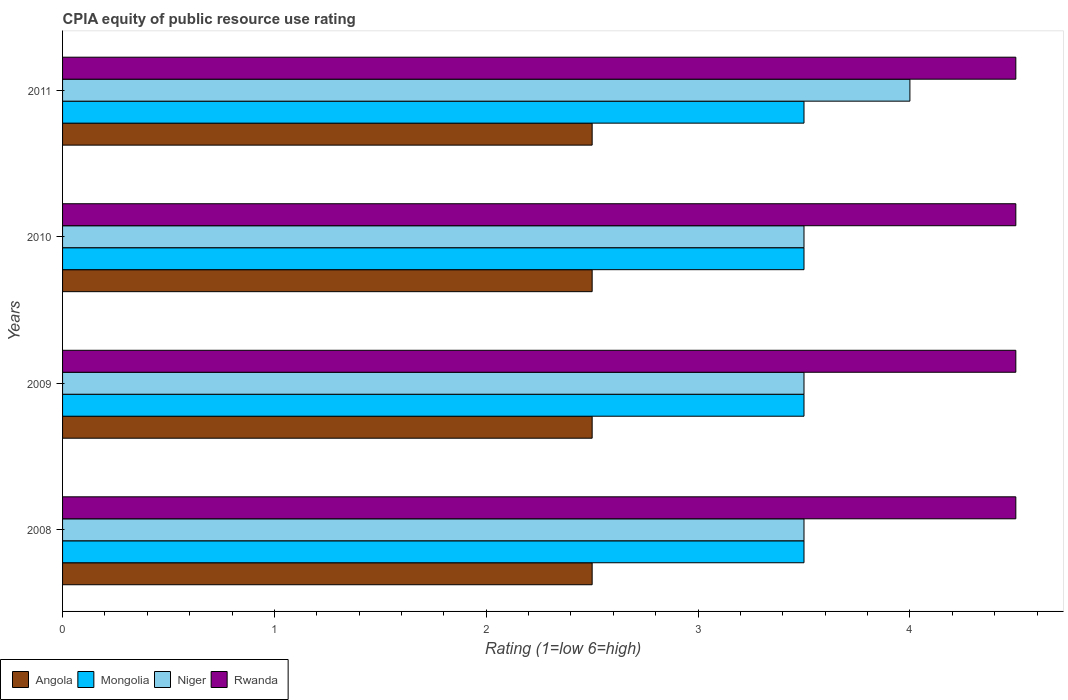How many different coloured bars are there?
Provide a short and direct response. 4. How many groups of bars are there?
Offer a terse response. 4. How many bars are there on the 3rd tick from the bottom?
Keep it short and to the point. 4. What is the label of the 2nd group of bars from the top?
Make the answer very short. 2010. In how many cases, is the number of bars for a given year not equal to the number of legend labels?
Your answer should be compact. 0. Across all years, what is the maximum CPIA rating in Niger?
Give a very brief answer. 4. In which year was the CPIA rating in Mongolia maximum?
Your answer should be compact. 2008. What is the difference between the CPIA rating in Rwanda in 2009 and that in 2011?
Offer a very short reply. 0. What is the difference between the CPIA rating in Mongolia in 2009 and the CPIA rating in Niger in 2008?
Give a very brief answer. 0. What is the average CPIA rating in Rwanda per year?
Give a very brief answer. 4.5. In how many years, is the CPIA rating in Angola greater than 0.2 ?
Your response must be concise. 4. What is the ratio of the CPIA rating in Angola in 2008 to that in 2010?
Make the answer very short. 1. Is the CPIA rating in Rwanda in 2008 less than that in 2011?
Offer a terse response. No. What is the difference between the highest and the second highest CPIA rating in Mongolia?
Provide a short and direct response. 0. What is the difference between the highest and the lowest CPIA rating in Niger?
Your answer should be compact. 0.5. What does the 2nd bar from the top in 2011 represents?
Your answer should be compact. Niger. What does the 3rd bar from the bottom in 2009 represents?
Your answer should be very brief. Niger. How many years are there in the graph?
Ensure brevity in your answer.  4. What is the difference between two consecutive major ticks on the X-axis?
Provide a succinct answer. 1. Does the graph contain grids?
Offer a terse response. No. Where does the legend appear in the graph?
Provide a short and direct response. Bottom left. How are the legend labels stacked?
Ensure brevity in your answer.  Horizontal. What is the title of the graph?
Give a very brief answer. CPIA equity of public resource use rating. Does "South Asia" appear as one of the legend labels in the graph?
Ensure brevity in your answer.  No. What is the label or title of the X-axis?
Ensure brevity in your answer.  Rating (1=low 6=high). What is the label or title of the Y-axis?
Give a very brief answer. Years. What is the Rating (1=low 6=high) of Angola in 2008?
Ensure brevity in your answer.  2.5. What is the Rating (1=low 6=high) in Niger in 2008?
Give a very brief answer. 3.5. What is the Rating (1=low 6=high) of Angola in 2009?
Keep it short and to the point. 2.5. What is the Rating (1=low 6=high) of Mongolia in 2009?
Provide a succinct answer. 3.5. What is the Rating (1=low 6=high) in Angola in 2010?
Keep it short and to the point. 2.5. What is the Rating (1=low 6=high) in Niger in 2010?
Offer a very short reply. 3.5. What is the Rating (1=low 6=high) of Angola in 2011?
Provide a succinct answer. 2.5. Across all years, what is the maximum Rating (1=low 6=high) of Angola?
Your answer should be very brief. 2.5. Across all years, what is the maximum Rating (1=low 6=high) in Mongolia?
Offer a terse response. 3.5. Across all years, what is the maximum Rating (1=low 6=high) in Niger?
Offer a terse response. 4. Across all years, what is the minimum Rating (1=low 6=high) in Angola?
Provide a succinct answer. 2.5. Across all years, what is the minimum Rating (1=low 6=high) of Mongolia?
Provide a succinct answer. 3.5. Across all years, what is the minimum Rating (1=low 6=high) of Rwanda?
Keep it short and to the point. 4.5. What is the total Rating (1=low 6=high) in Angola in the graph?
Make the answer very short. 10. What is the total Rating (1=low 6=high) of Mongolia in the graph?
Keep it short and to the point. 14. What is the total Rating (1=low 6=high) in Niger in the graph?
Offer a very short reply. 14.5. What is the total Rating (1=low 6=high) in Rwanda in the graph?
Provide a succinct answer. 18. What is the difference between the Rating (1=low 6=high) in Mongolia in 2008 and that in 2009?
Offer a very short reply. 0. What is the difference between the Rating (1=low 6=high) in Niger in 2008 and that in 2009?
Make the answer very short. 0. What is the difference between the Rating (1=low 6=high) of Angola in 2008 and that in 2010?
Offer a terse response. 0. What is the difference between the Rating (1=low 6=high) in Rwanda in 2008 and that in 2010?
Your answer should be very brief. 0. What is the difference between the Rating (1=low 6=high) of Angola in 2008 and that in 2011?
Your response must be concise. 0. What is the difference between the Rating (1=low 6=high) in Mongolia in 2008 and that in 2011?
Your response must be concise. 0. What is the difference between the Rating (1=low 6=high) of Rwanda in 2008 and that in 2011?
Your response must be concise. 0. What is the difference between the Rating (1=low 6=high) of Angola in 2009 and that in 2010?
Make the answer very short. 0. What is the difference between the Rating (1=low 6=high) in Mongolia in 2009 and that in 2010?
Offer a very short reply. 0. What is the difference between the Rating (1=low 6=high) of Niger in 2009 and that in 2010?
Your response must be concise. 0. What is the difference between the Rating (1=low 6=high) in Angola in 2009 and that in 2011?
Provide a succinct answer. 0. What is the difference between the Rating (1=low 6=high) in Mongolia in 2009 and that in 2011?
Provide a succinct answer. 0. What is the difference between the Rating (1=low 6=high) of Rwanda in 2009 and that in 2011?
Your response must be concise. 0. What is the difference between the Rating (1=low 6=high) of Angola in 2010 and that in 2011?
Your answer should be compact. 0. What is the difference between the Rating (1=low 6=high) of Angola in 2008 and the Rating (1=low 6=high) of Mongolia in 2009?
Provide a succinct answer. -1. What is the difference between the Rating (1=low 6=high) in Mongolia in 2008 and the Rating (1=low 6=high) in Niger in 2009?
Provide a short and direct response. 0. What is the difference between the Rating (1=low 6=high) of Mongolia in 2008 and the Rating (1=low 6=high) of Rwanda in 2009?
Your answer should be compact. -1. What is the difference between the Rating (1=low 6=high) of Angola in 2008 and the Rating (1=low 6=high) of Mongolia in 2010?
Your answer should be very brief. -1. What is the difference between the Rating (1=low 6=high) in Angola in 2008 and the Rating (1=low 6=high) in Niger in 2010?
Provide a succinct answer. -1. What is the difference between the Rating (1=low 6=high) of Mongolia in 2008 and the Rating (1=low 6=high) of Rwanda in 2010?
Make the answer very short. -1. What is the difference between the Rating (1=low 6=high) in Niger in 2008 and the Rating (1=low 6=high) in Rwanda in 2010?
Ensure brevity in your answer.  -1. What is the difference between the Rating (1=low 6=high) of Mongolia in 2008 and the Rating (1=low 6=high) of Niger in 2011?
Offer a very short reply. -0.5. What is the difference between the Rating (1=low 6=high) in Niger in 2008 and the Rating (1=low 6=high) in Rwanda in 2011?
Ensure brevity in your answer.  -1. What is the difference between the Rating (1=low 6=high) of Angola in 2009 and the Rating (1=low 6=high) of Mongolia in 2010?
Your answer should be compact. -1. What is the difference between the Rating (1=low 6=high) of Angola in 2009 and the Rating (1=low 6=high) of Rwanda in 2010?
Your answer should be compact. -2. What is the difference between the Rating (1=low 6=high) in Mongolia in 2009 and the Rating (1=low 6=high) in Rwanda in 2010?
Your answer should be very brief. -1. What is the difference between the Rating (1=low 6=high) in Angola in 2009 and the Rating (1=low 6=high) in Mongolia in 2011?
Offer a terse response. -1. What is the difference between the Rating (1=low 6=high) in Angola in 2009 and the Rating (1=low 6=high) in Rwanda in 2011?
Your answer should be very brief. -2. What is the difference between the Rating (1=low 6=high) of Mongolia in 2009 and the Rating (1=low 6=high) of Niger in 2011?
Your answer should be compact. -0.5. What is the difference between the Rating (1=low 6=high) of Mongolia in 2009 and the Rating (1=low 6=high) of Rwanda in 2011?
Your answer should be very brief. -1. What is the difference between the Rating (1=low 6=high) in Angola in 2010 and the Rating (1=low 6=high) in Mongolia in 2011?
Your answer should be very brief. -1. What is the difference between the Rating (1=low 6=high) in Angola in 2010 and the Rating (1=low 6=high) in Rwanda in 2011?
Your response must be concise. -2. What is the difference between the Rating (1=low 6=high) in Mongolia in 2010 and the Rating (1=low 6=high) in Niger in 2011?
Provide a short and direct response. -0.5. What is the difference between the Rating (1=low 6=high) of Mongolia in 2010 and the Rating (1=low 6=high) of Rwanda in 2011?
Ensure brevity in your answer.  -1. What is the average Rating (1=low 6=high) of Angola per year?
Ensure brevity in your answer.  2.5. What is the average Rating (1=low 6=high) of Niger per year?
Offer a terse response. 3.62. In the year 2008, what is the difference between the Rating (1=low 6=high) in Angola and Rating (1=low 6=high) in Mongolia?
Offer a very short reply. -1. In the year 2008, what is the difference between the Rating (1=low 6=high) of Angola and Rating (1=low 6=high) of Niger?
Make the answer very short. -1. In the year 2008, what is the difference between the Rating (1=low 6=high) of Mongolia and Rating (1=low 6=high) of Niger?
Offer a terse response. 0. In the year 2008, what is the difference between the Rating (1=low 6=high) in Niger and Rating (1=low 6=high) in Rwanda?
Offer a very short reply. -1. In the year 2009, what is the difference between the Rating (1=low 6=high) in Mongolia and Rating (1=low 6=high) in Niger?
Your answer should be compact. 0. In the year 2010, what is the difference between the Rating (1=low 6=high) of Angola and Rating (1=low 6=high) of Niger?
Ensure brevity in your answer.  -1. In the year 2010, what is the difference between the Rating (1=low 6=high) in Mongolia and Rating (1=low 6=high) in Niger?
Offer a terse response. 0. In the year 2010, what is the difference between the Rating (1=low 6=high) of Mongolia and Rating (1=low 6=high) of Rwanda?
Your answer should be compact. -1. In the year 2010, what is the difference between the Rating (1=low 6=high) in Niger and Rating (1=low 6=high) in Rwanda?
Keep it short and to the point. -1. In the year 2011, what is the difference between the Rating (1=low 6=high) of Angola and Rating (1=low 6=high) of Mongolia?
Your answer should be very brief. -1. In the year 2011, what is the difference between the Rating (1=low 6=high) in Angola and Rating (1=low 6=high) in Niger?
Provide a succinct answer. -1.5. In the year 2011, what is the difference between the Rating (1=low 6=high) of Mongolia and Rating (1=low 6=high) of Rwanda?
Give a very brief answer. -1. What is the ratio of the Rating (1=low 6=high) in Angola in 2008 to that in 2009?
Offer a very short reply. 1. What is the ratio of the Rating (1=low 6=high) of Rwanda in 2008 to that in 2009?
Provide a succinct answer. 1. What is the ratio of the Rating (1=low 6=high) in Mongolia in 2008 to that in 2010?
Ensure brevity in your answer.  1. What is the ratio of the Rating (1=low 6=high) in Angola in 2008 to that in 2011?
Give a very brief answer. 1. What is the ratio of the Rating (1=low 6=high) of Mongolia in 2008 to that in 2011?
Give a very brief answer. 1. What is the ratio of the Rating (1=low 6=high) in Niger in 2008 to that in 2011?
Give a very brief answer. 0.88. What is the ratio of the Rating (1=low 6=high) of Rwanda in 2008 to that in 2011?
Your answer should be compact. 1. What is the ratio of the Rating (1=low 6=high) of Angola in 2009 to that in 2010?
Provide a succinct answer. 1. What is the ratio of the Rating (1=low 6=high) of Niger in 2009 to that in 2010?
Offer a very short reply. 1. What is the ratio of the Rating (1=low 6=high) of Mongolia in 2009 to that in 2011?
Offer a terse response. 1. What is the difference between the highest and the second highest Rating (1=low 6=high) in Mongolia?
Provide a succinct answer. 0. What is the difference between the highest and the second highest Rating (1=low 6=high) of Rwanda?
Provide a short and direct response. 0. What is the difference between the highest and the lowest Rating (1=low 6=high) of Mongolia?
Your answer should be very brief. 0. What is the difference between the highest and the lowest Rating (1=low 6=high) of Rwanda?
Give a very brief answer. 0. 